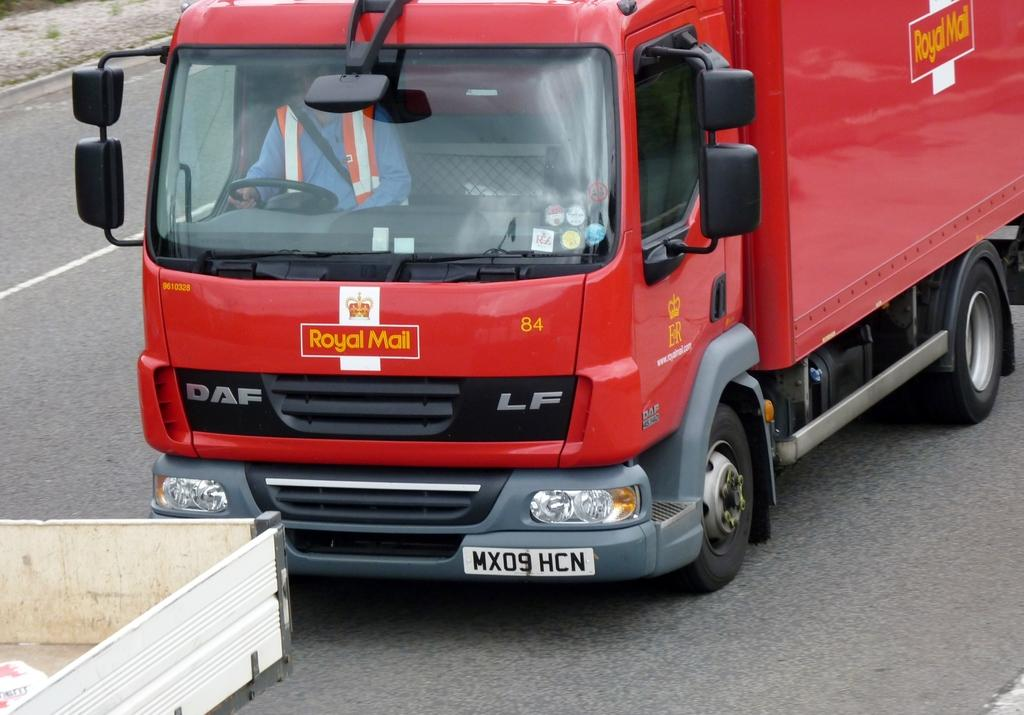What can be seen on the road in the image? There are vehicles on the road in the image. Can you describe the person inside one of the vehicles? There is a man inside a vehicle in the image. What is a feature of the vehicle that can be used for identification? The vehicle has a number plate. What does the servant say from the edge of the mouth in the image? There is no servant or mouth present in the image. 